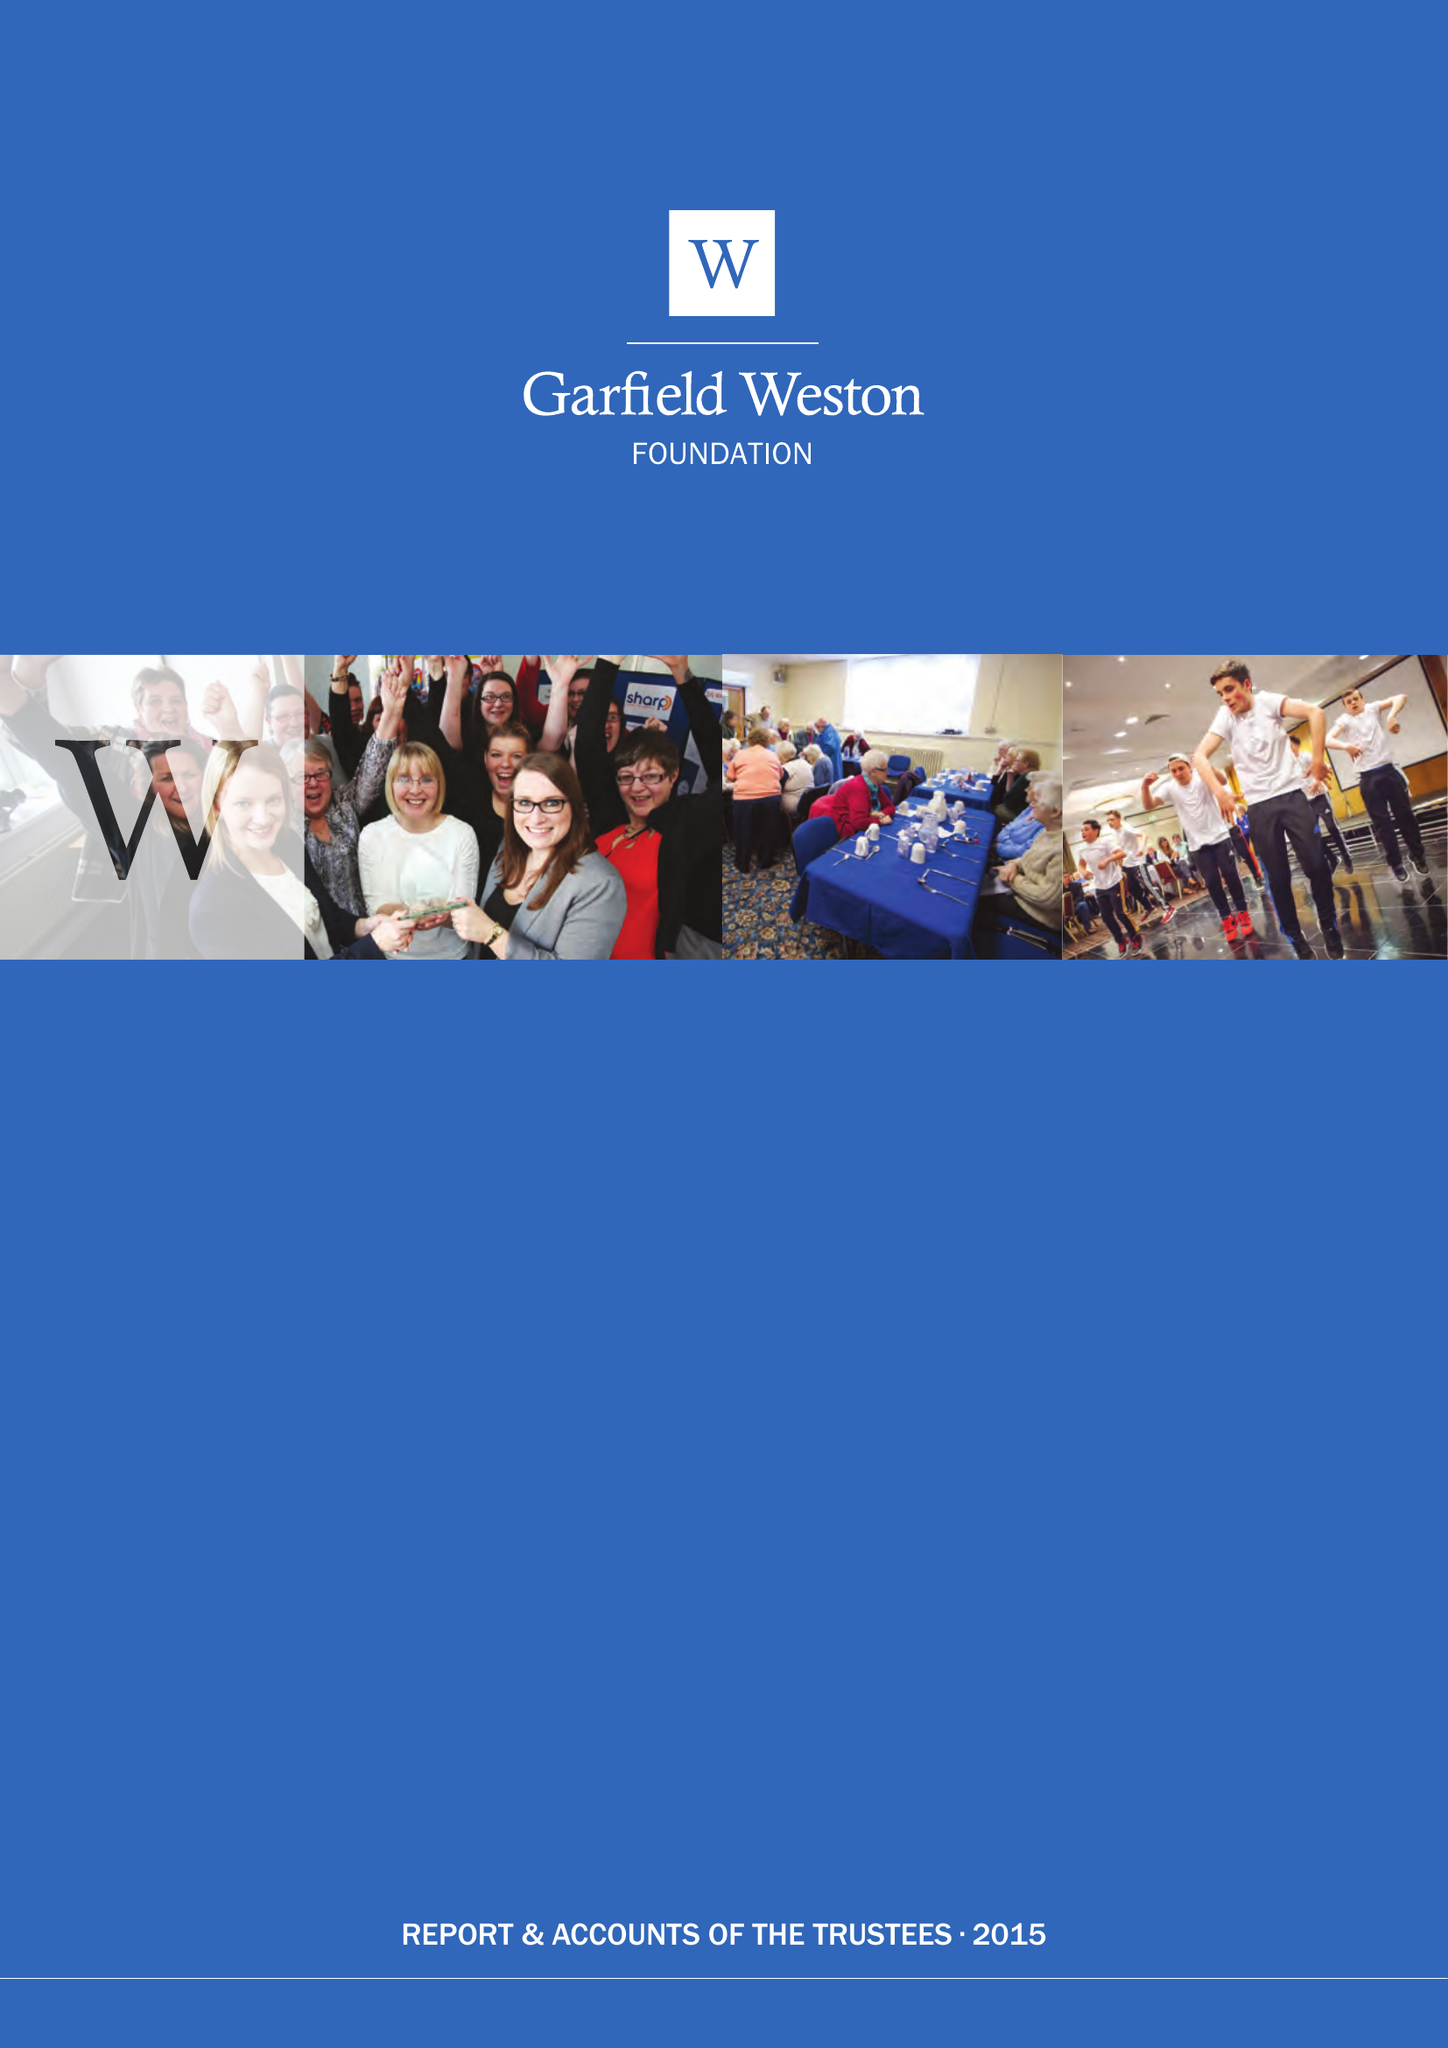What is the value for the charity_name?
Answer the question using a single word or phrase. Garfield Weston Foundation 